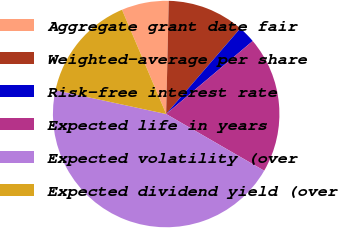Convert chart to OTSL. <chart><loc_0><loc_0><loc_500><loc_500><pie_chart><fcel>Aggregate grant date fair<fcel>Weighted-average per share<fcel>Risk-free interest rate<fcel>Expected life in years<fcel>Expected volatility (over<fcel>Expected dividend yield (over<nl><fcel>6.74%<fcel>10.99%<fcel>2.49%<fcel>19.5%<fcel>45.03%<fcel>15.25%<nl></chart> 